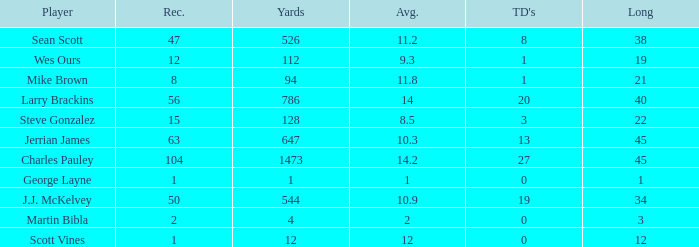Could you parse the entire table? {'header': ['Player', 'Rec.', 'Yards', 'Avg.', "TD's", 'Long'], 'rows': [['Sean Scott', '47', '526', '11.2', '8', '38'], ['Wes Ours', '12', '112', '9.3', '1', '19'], ['Mike Brown', '8', '94', '11.8', '1', '21'], ['Larry Brackins', '56', '786', '14', '20', '40'], ['Steve Gonzalez', '15', '128', '8.5', '3', '22'], ['Jerrian James', '63', '647', '10.3', '13', '45'], ['Charles Pauley', '104', '1473', '14.2', '27', '45'], ['George Layne', '1', '1', '1', '0', '1'], ['J.J. McKelvey', '50', '544', '10.9', '19', '34'], ['Martin Bibla', '2', '4', '2', '0', '3'], ['Scott Vines', '1', '12', '12', '0', '12']]} How many receptions for players with over 647 yards and an under 14 yard average? None. 